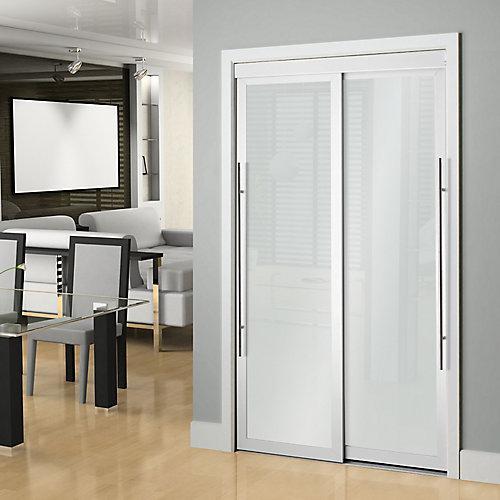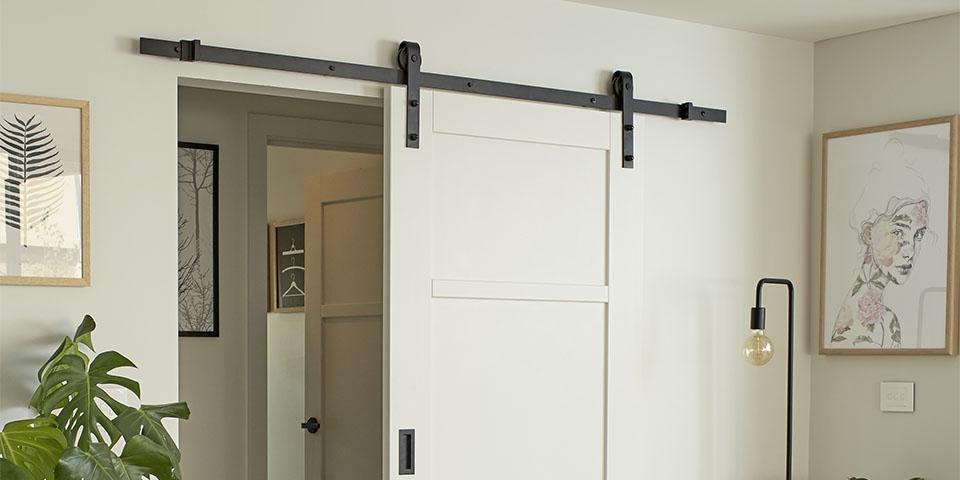The first image is the image on the left, the second image is the image on the right. Examine the images to the left and right. Is the description "There is  total of two white hanging doors." accurate? Answer yes or no. No. 